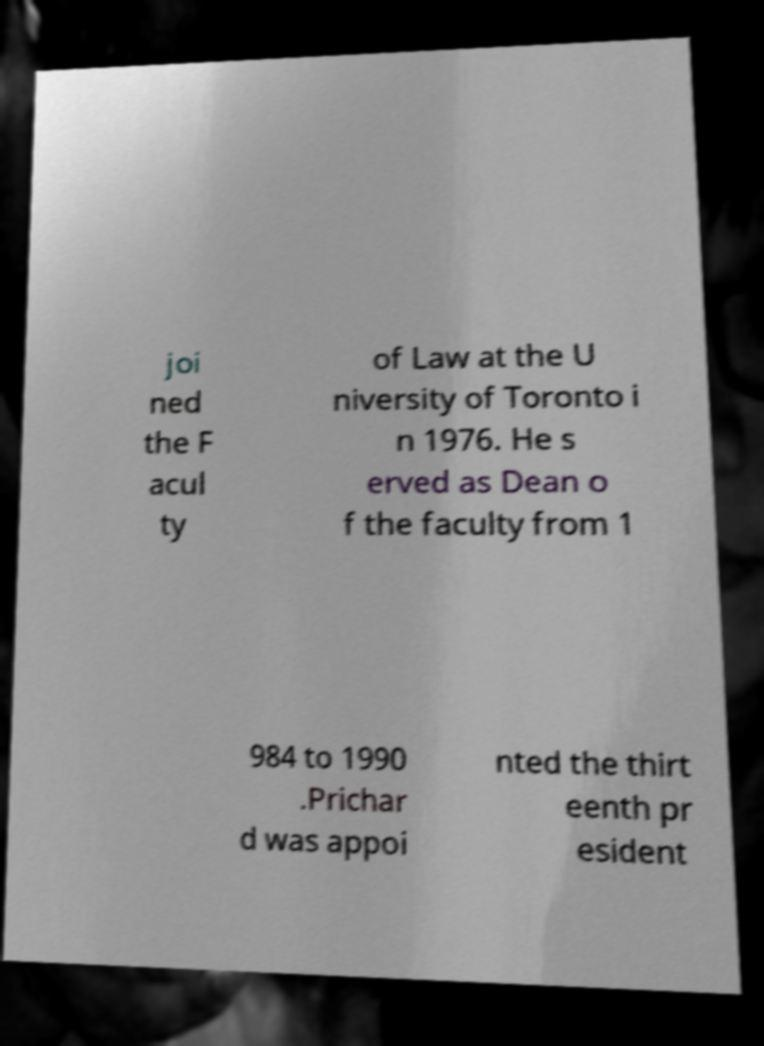Please identify and transcribe the text found in this image. joi ned the F acul ty of Law at the U niversity of Toronto i n 1976. He s erved as Dean o f the faculty from 1 984 to 1990 .Prichar d was appoi nted the thirt eenth pr esident 